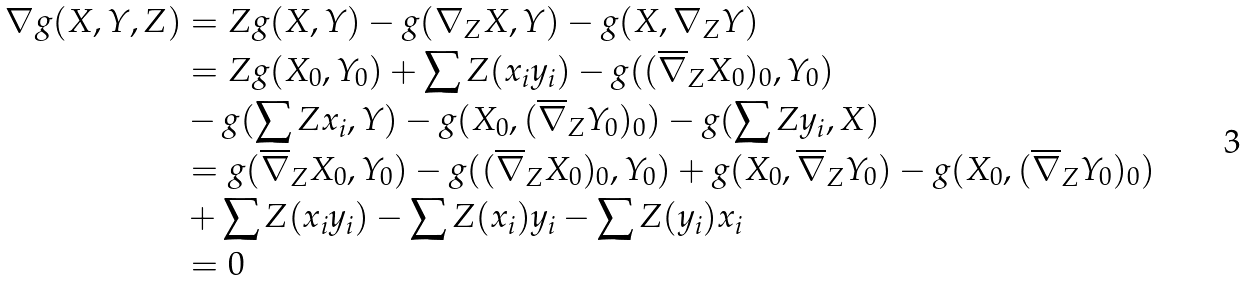Convert formula to latex. <formula><loc_0><loc_0><loc_500><loc_500>\nabla g ( X , Y , Z ) & = Z g ( X , Y ) - g ( \nabla _ { Z } X , Y ) - g ( X , \nabla _ { Z } Y ) \\ & = Z g ( X _ { 0 } , Y _ { 0 } ) + \sum Z ( x _ { i } y _ { i } ) - g ( ( \overline { \nabla } _ { Z } X _ { 0 } ) _ { 0 } , Y _ { 0 } ) \\ & - g ( \sum Z x _ { i } , Y ) - g ( X _ { 0 } , ( \overline { \nabla } _ { Z } Y _ { 0 } ) _ { 0 } ) - g ( \sum Z y _ { i } , X ) \\ & = g ( \overline { \nabla } _ { Z } X _ { 0 } , Y _ { 0 } ) - g ( ( \overline { \nabla } _ { Z } X _ { 0 } ) _ { 0 } , Y _ { 0 } ) + g ( X _ { 0 } , \overline { \nabla } _ { Z } Y _ { 0 } ) - g ( X _ { 0 } , ( \overline { \nabla } _ { Z } Y _ { 0 } ) _ { 0 } ) \\ & + \sum Z ( x _ { i } y _ { i } ) - \sum Z ( x _ { i } ) y _ { i } - \sum Z ( y _ { i } ) x _ { i } \\ & = 0</formula> 